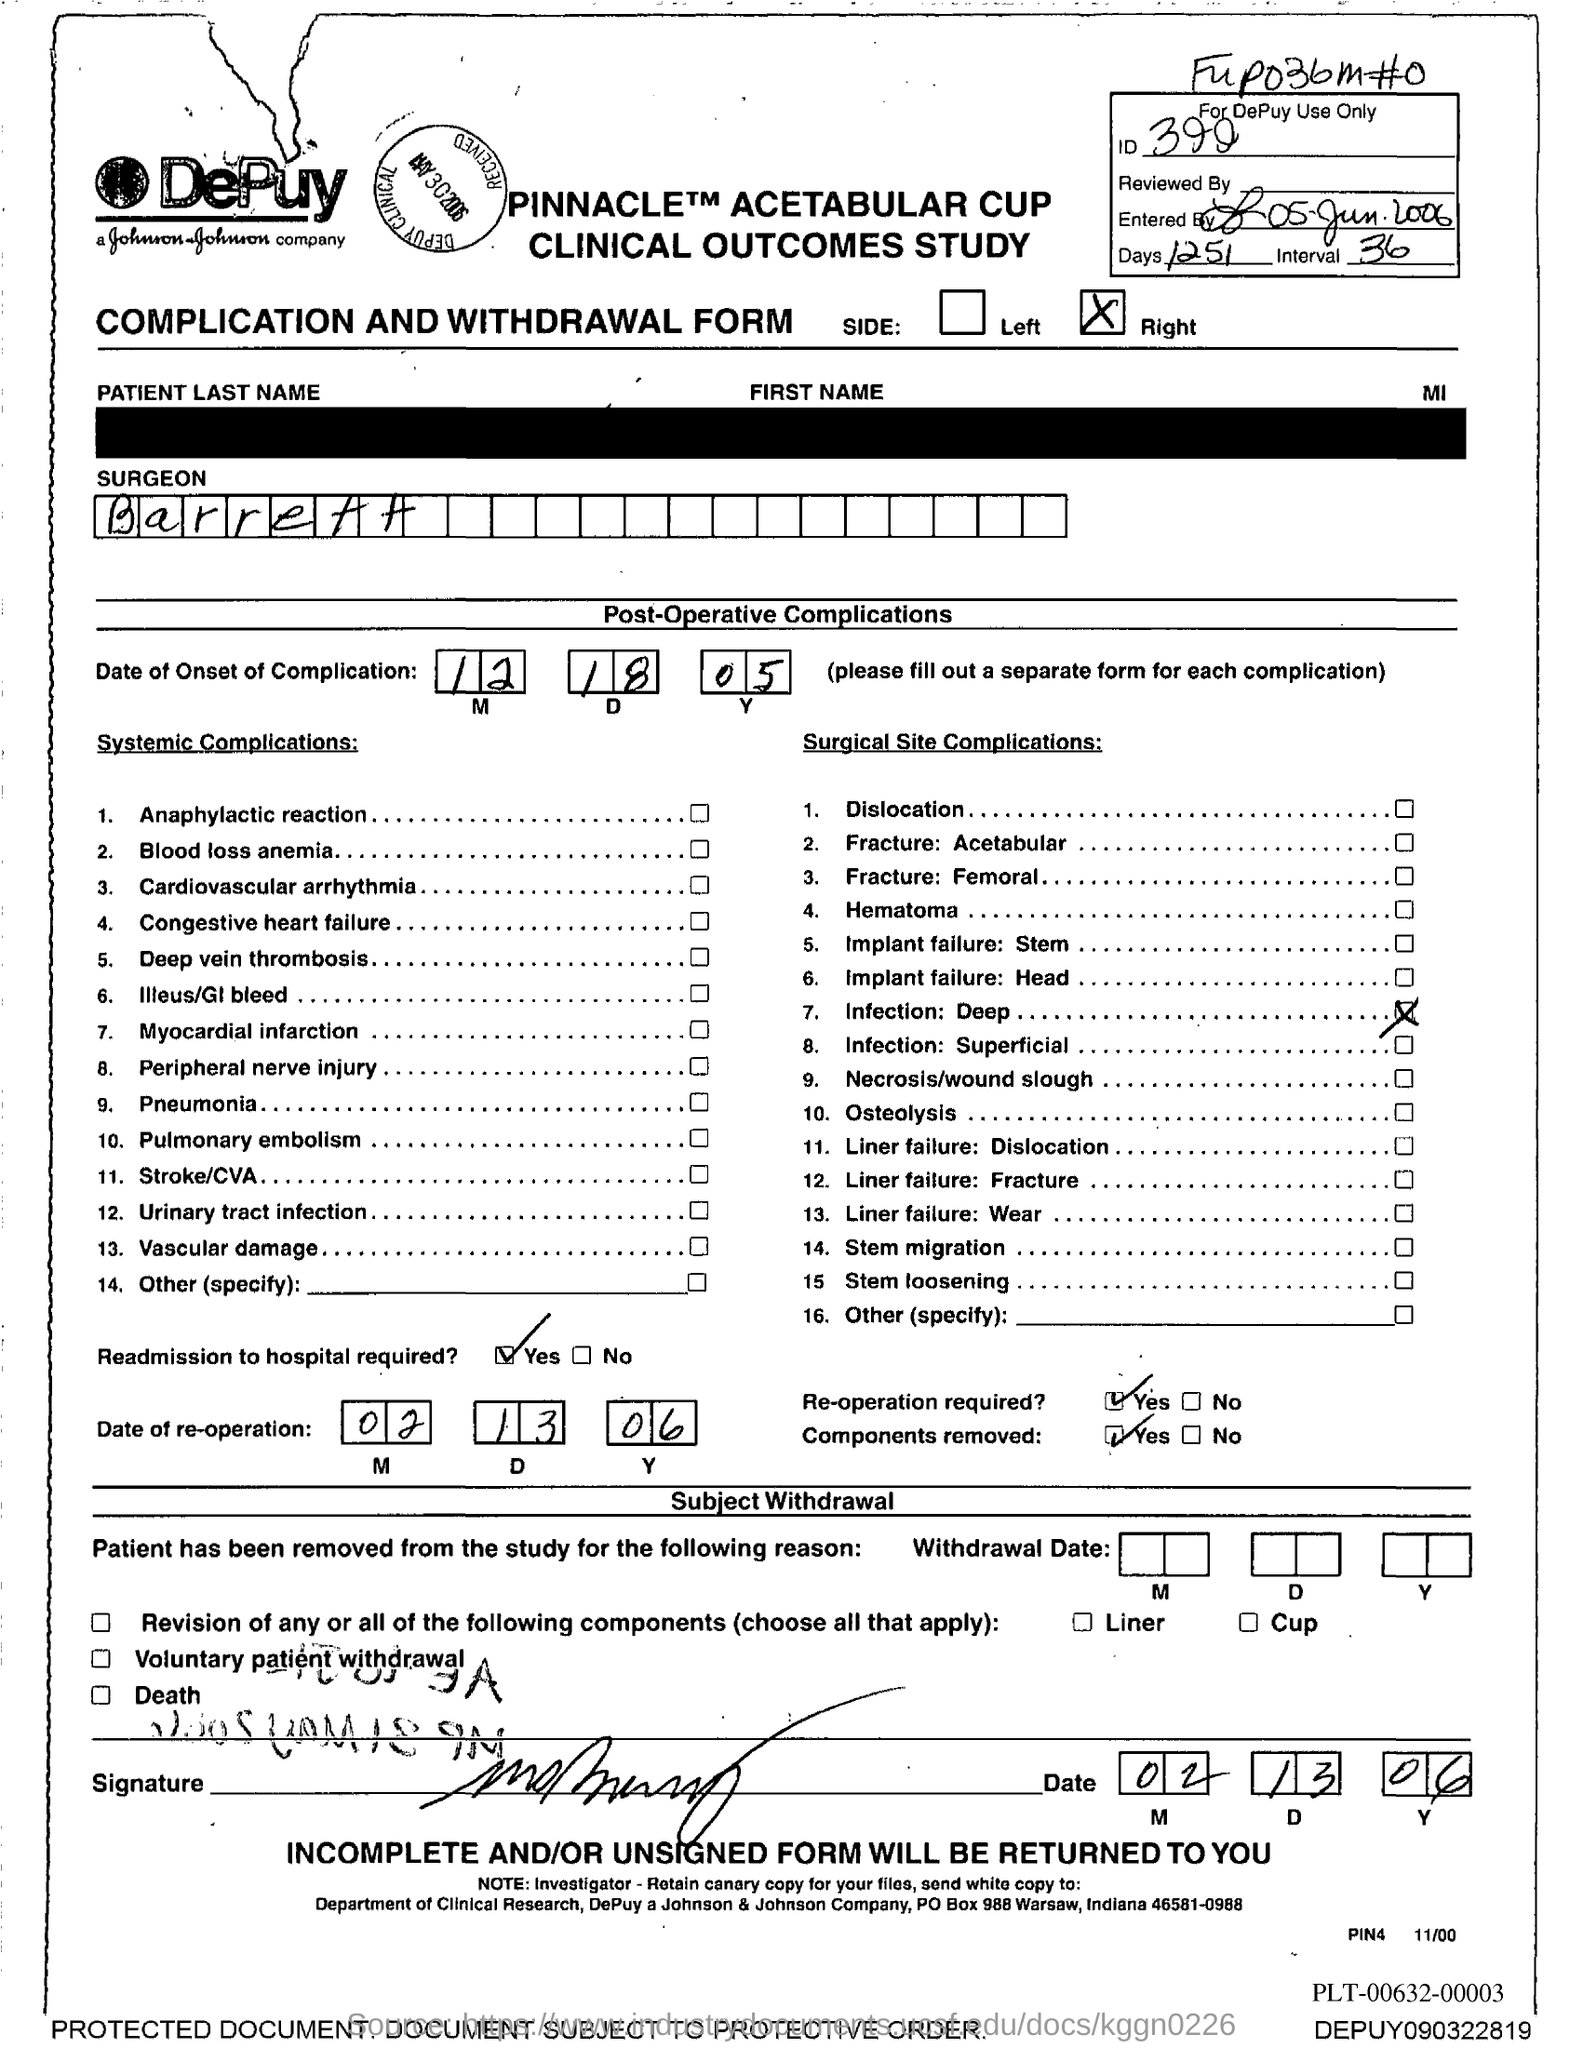Mention a couple of crucial points in this snapshot. Number 2 under 'Systemic Complications' is written with reference to blood loss anemia. The word 'SURGEON' is written under the name 'Barrett', and the name 'Barrett' is followed by the name 'Barrett'. The last item under the heading "Systemic Complications" is numbered 14. The PO Box number given is 988 Warsaw. The complication of osteolysis is listed under 'Surgical Site Complications' in the tenth entry. 